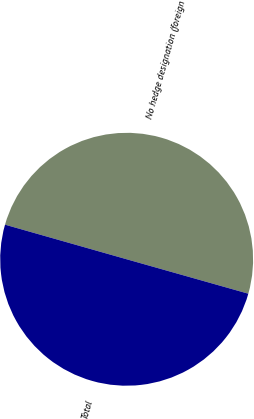<chart> <loc_0><loc_0><loc_500><loc_500><pie_chart><fcel>No hedge designation (foreign<fcel>Total<nl><fcel>49.98%<fcel>50.02%<nl></chart> 